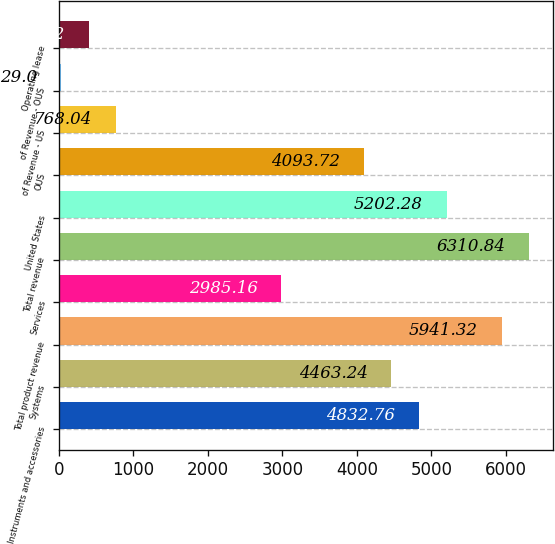<chart> <loc_0><loc_0><loc_500><loc_500><bar_chart><fcel>Instruments and accessories<fcel>Systems<fcel>Total product revenue<fcel>Services<fcel>Total revenue<fcel>United States<fcel>OUS<fcel>of Revenue - US<fcel>of Revenue - OUS<fcel>Operating lease<nl><fcel>4832.76<fcel>4463.24<fcel>5941.32<fcel>2985.16<fcel>6310.84<fcel>5202.28<fcel>4093.72<fcel>768.04<fcel>29<fcel>398.52<nl></chart> 